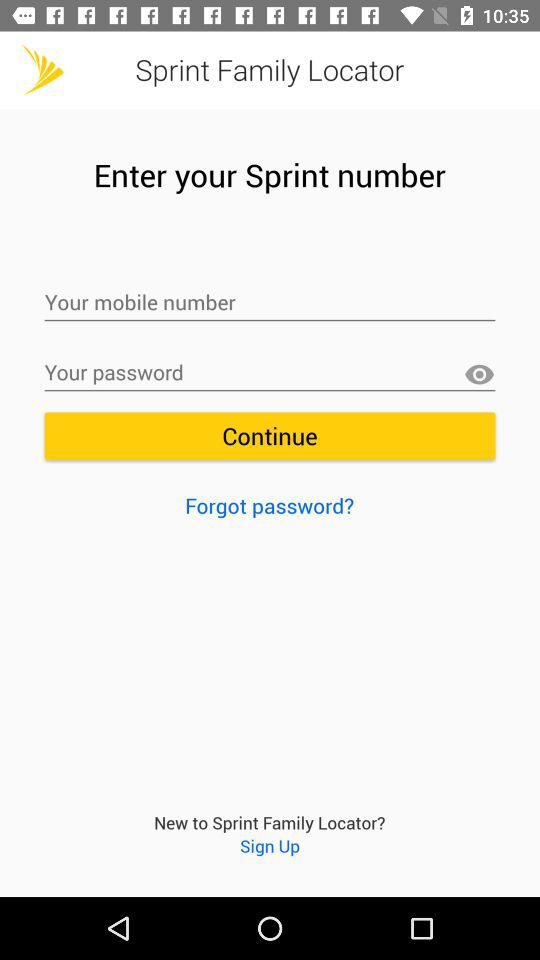What is the application name? The application name is "Sprint Family Locator". 